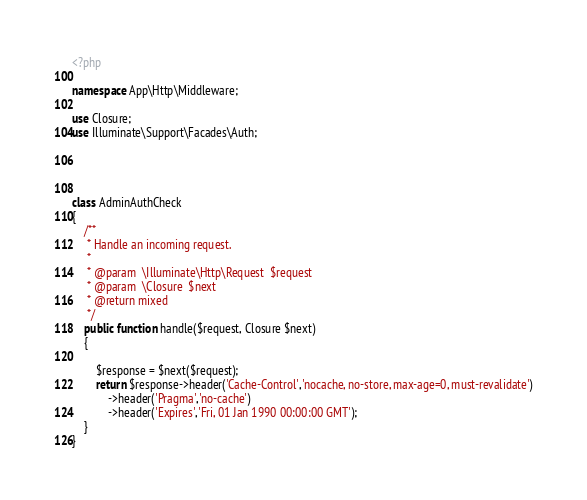Convert code to text. <code><loc_0><loc_0><loc_500><loc_500><_PHP_><?php

namespace App\Http\Middleware;

use Closure;
use Illuminate\Support\Facades\Auth;




class AdminAuthCheck
{
    /**
     * Handle an incoming request.
     *
     * @param  \Illuminate\Http\Request  $request
     * @param  \Closure  $next
     * @return mixed
     */
    public function handle($request, Closure $next)
    {
        
        $response = $next($request);
        return $response->header('Cache-Control','nocache, no-store, max-age=0, must-revalidate')
            ->header('Pragma','no-cache')
            ->header('Expires','Fri, 01 Jan 1990 00:00:00 GMT');
    }
}
</code> 